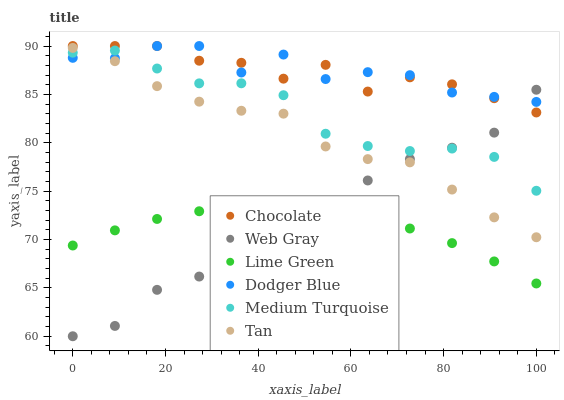Does Lime Green have the minimum area under the curve?
Answer yes or no. Yes. Does Dodger Blue have the maximum area under the curve?
Answer yes or no. Yes. Does Chocolate have the minimum area under the curve?
Answer yes or no. No. Does Chocolate have the maximum area under the curve?
Answer yes or no. No. Is Lime Green the smoothest?
Answer yes or no. Yes. Is Dodger Blue the roughest?
Answer yes or no. Yes. Is Chocolate the smoothest?
Answer yes or no. No. Is Chocolate the roughest?
Answer yes or no. No. Does Web Gray have the lowest value?
Answer yes or no. Yes. Does Chocolate have the lowest value?
Answer yes or no. No. Does Dodger Blue have the highest value?
Answer yes or no. Yes. Does Medium Turquoise have the highest value?
Answer yes or no. No. Is Lime Green less than Tan?
Answer yes or no. Yes. Is Tan greater than Lime Green?
Answer yes or no. Yes. Does Dodger Blue intersect Web Gray?
Answer yes or no. Yes. Is Dodger Blue less than Web Gray?
Answer yes or no. No. Is Dodger Blue greater than Web Gray?
Answer yes or no. No. Does Lime Green intersect Tan?
Answer yes or no. No. 